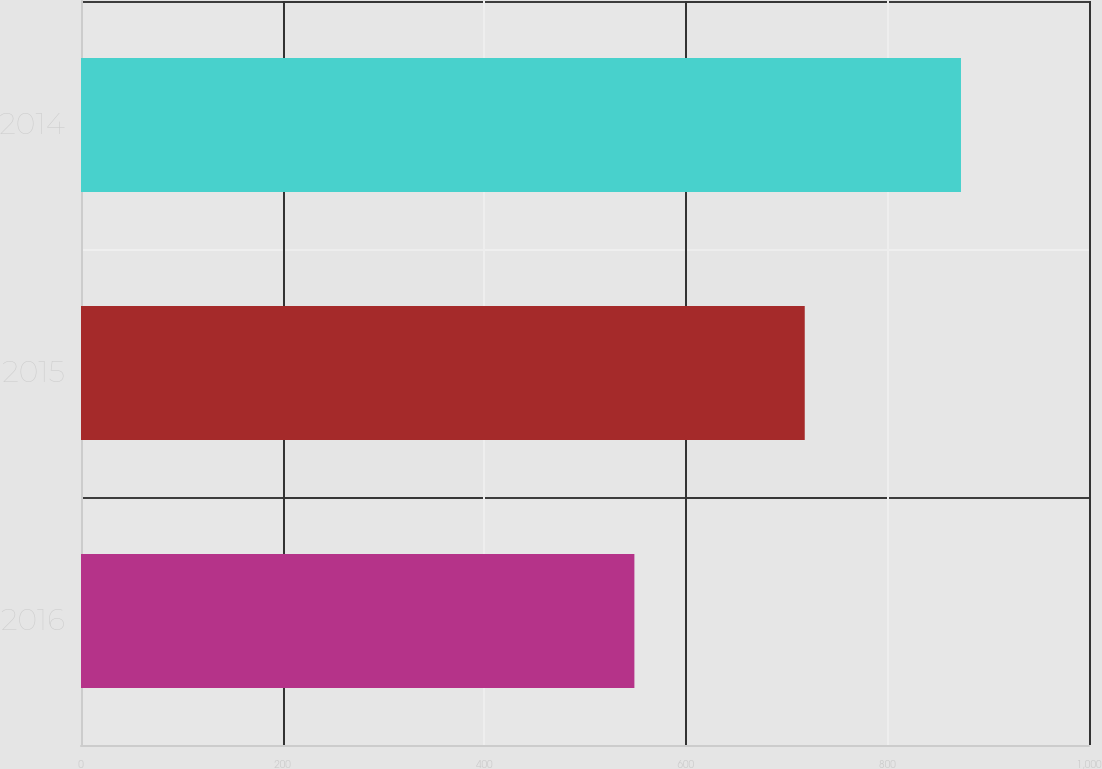Convert chart. <chart><loc_0><loc_0><loc_500><loc_500><bar_chart><fcel>2016<fcel>2015<fcel>2014<nl><fcel>549<fcel>718<fcel>873<nl></chart> 